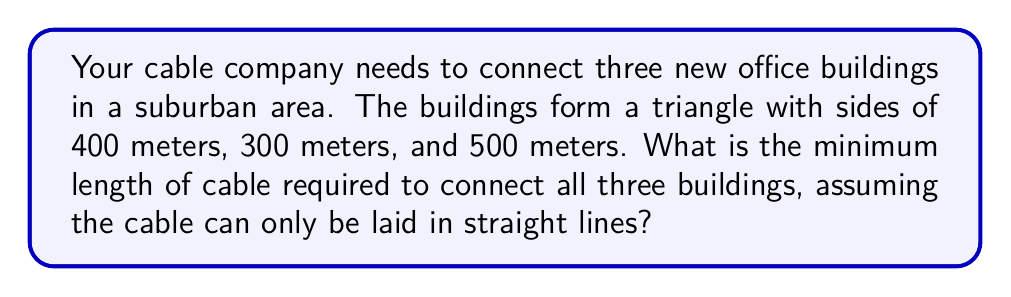What is the answer to this math problem? To solve this problem, we need to use the concept of the Steiner tree, specifically for three points. The shortest path connecting three points is known as the Fermat point or the 1-Steiner point.

Step 1: Determine if the triangle is obtuse.
First, we need to check if the largest angle in the triangle is greater than or equal to 120°. We can use the cosine law to find the largest angle:

$$ \cos A = \frac{b^2 + c^2 - a^2}{2bc} $$

Where $a$ is the longest side (500m), $b$ and $c$ are the other two sides (400m and 300m).

$$ \cos A = \frac{400^2 + 300^2 - 500^2}{2 \cdot 400 \cdot 300} \approx 0.375 $$

$$ A = \arccos(0.375) \approx 68.0° $$

Since the largest angle is less than 120°, we proceed to find the Fermat point.

Step 2: Construct equilateral triangles on each side of the original triangle.
[asy]
unitsize(0.1cm);
pair A = (0,0), B = (40,0), C = (20,34.64);
draw(A--B--C--cycle);
pair D = (60,34.64);
pair E = (-20,34.64);
pair F = (20,-34.64);
draw(A--C--D--cycle,dashed);
draw(A--B--F--cycle,dashed);
draw(B--C--E--cycle,dashed);
dot(A); dot(B); dot(C);
label("A",A,SW);
label("B",B,SE);
label("C",C,N);
label("400m",B/2,S);
label("300m",(A+C)/2,NW);
label("500m",(B+C)/2,NE);
[/asy]

Step 3: Connect the outer vertices of the equilateral triangles to the opposite vertices of the original triangle.
The intersection point of these lines is the Fermat point.

Step 4: Calculate the minimum cable length.
The minimum cable length is the sum of the distances from the Fermat point to each of the three buildings. This can be calculated using the following formula:

$$ L = \frac{a + b + c}{\sqrt{3}} $$

Where $a$, $b$, and $c$ are the side lengths of the original triangle.

$$ L = \frac{400 + 300 + 500}{\sqrt{3}} \approx 692.82 \text{ meters} $$

Therefore, the minimum length of cable required to connect all three buildings is approximately 692.82 meters.
Answer: 692.82 meters 